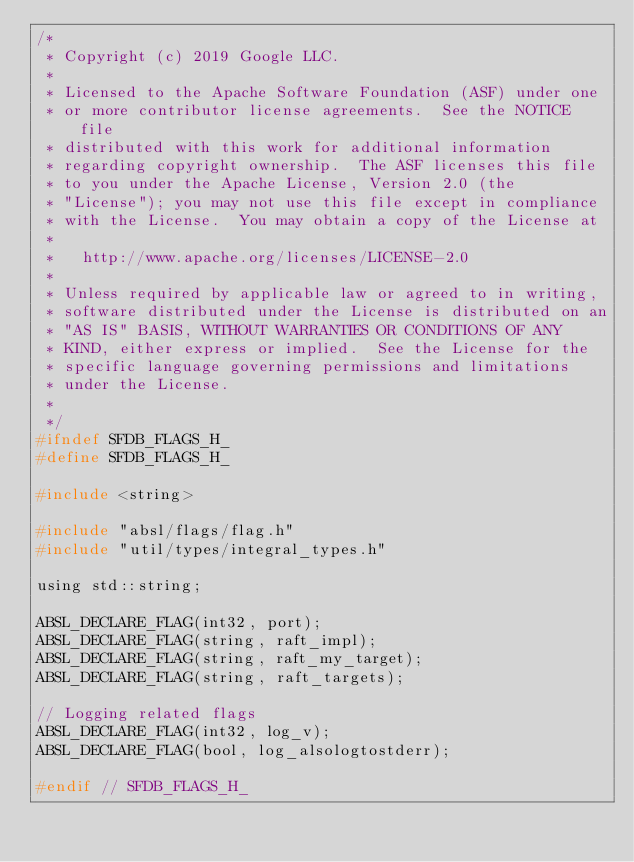<code> <loc_0><loc_0><loc_500><loc_500><_C_>/*
 * Copyright (c) 2019 Google LLC.
 *
 * Licensed to the Apache Software Foundation (ASF) under one
 * or more contributor license agreements.  See the NOTICE file
 * distributed with this work for additional information
 * regarding copyright ownership.  The ASF licenses this file
 * to you under the Apache License, Version 2.0 (the
 * "License"); you may not use this file except in compliance
 * with the License.  You may obtain a copy of the License at
 *
 *   http://www.apache.org/licenses/LICENSE-2.0
 *
 * Unless required by applicable law or agreed to in writing,
 * software distributed under the License is distributed on an
 * "AS IS" BASIS, WITHOUT WARRANTIES OR CONDITIONS OF ANY
 * KIND, either express or implied.  See the License for the
 * specific language governing permissions and limitations
 * under the License.
 *
 */
#ifndef SFDB_FLAGS_H_
#define SFDB_FLAGS_H_

#include <string>

#include "absl/flags/flag.h"
#include "util/types/integral_types.h"

using std::string;

ABSL_DECLARE_FLAG(int32, port);
ABSL_DECLARE_FLAG(string, raft_impl);
ABSL_DECLARE_FLAG(string, raft_my_target);
ABSL_DECLARE_FLAG(string, raft_targets);

// Logging related flags
ABSL_DECLARE_FLAG(int32, log_v);
ABSL_DECLARE_FLAG(bool, log_alsologtostderr);

#endif // SFDB_FLAGS_H_
</code> 